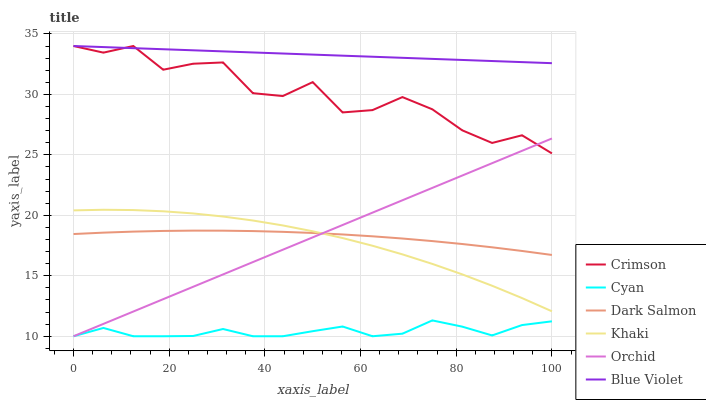Does Cyan have the minimum area under the curve?
Answer yes or no. Yes. Does Blue Violet have the maximum area under the curve?
Answer yes or no. Yes. Does Dark Salmon have the minimum area under the curve?
Answer yes or no. No. Does Dark Salmon have the maximum area under the curve?
Answer yes or no. No. Is Orchid the smoothest?
Answer yes or no. Yes. Is Crimson the roughest?
Answer yes or no. Yes. Is Dark Salmon the smoothest?
Answer yes or no. No. Is Dark Salmon the roughest?
Answer yes or no. No. Does Cyan have the lowest value?
Answer yes or no. Yes. Does Dark Salmon have the lowest value?
Answer yes or no. No. Does Blue Violet have the highest value?
Answer yes or no. Yes. Does Dark Salmon have the highest value?
Answer yes or no. No. Is Dark Salmon less than Blue Violet?
Answer yes or no. Yes. Is Crimson greater than Khaki?
Answer yes or no. Yes. Does Khaki intersect Dark Salmon?
Answer yes or no. Yes. Is Khaki less than Dark Salmon?
Answer yes or no. No. Is Khaki greater than Dark Salmon?
Answer yes or no. No. Does Dark Salmon intersect Blue Violet?
Answer yes or no. No. 